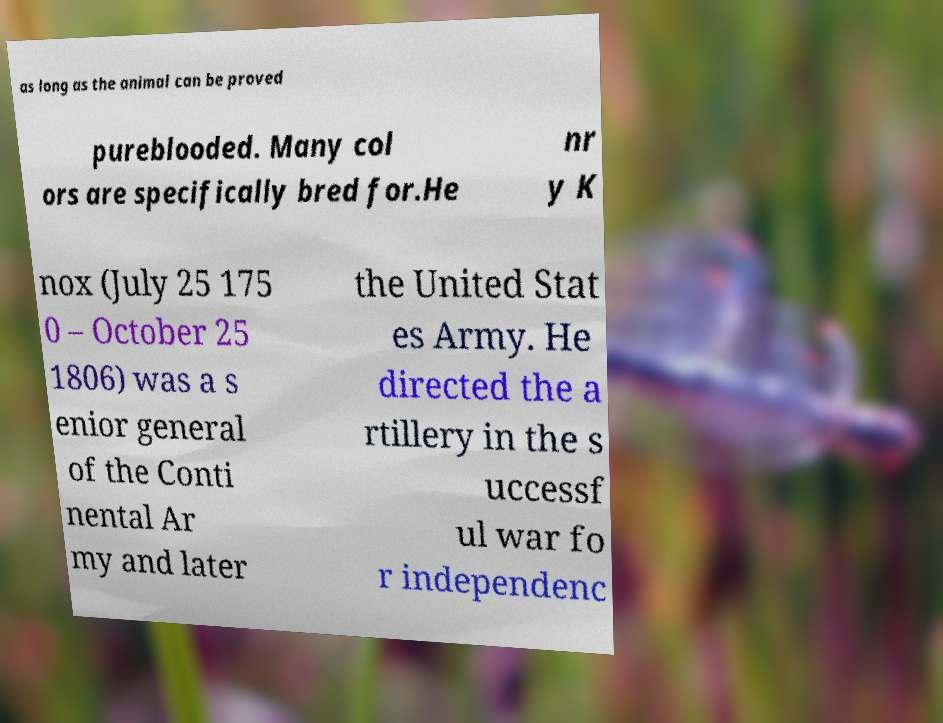For documentation purposes, I need the text within this image transcribed. Could you provide that? as long as the animal can be proved pureblooded. Many col ors are specifically bred for.He nr y K nox (July 25 175 0 – October 25 1806) was a s enior general of the Conti nental Ar my and later the United Stat es Army. He directed the a rtillery in the s uccessf ul war fo r independenc 